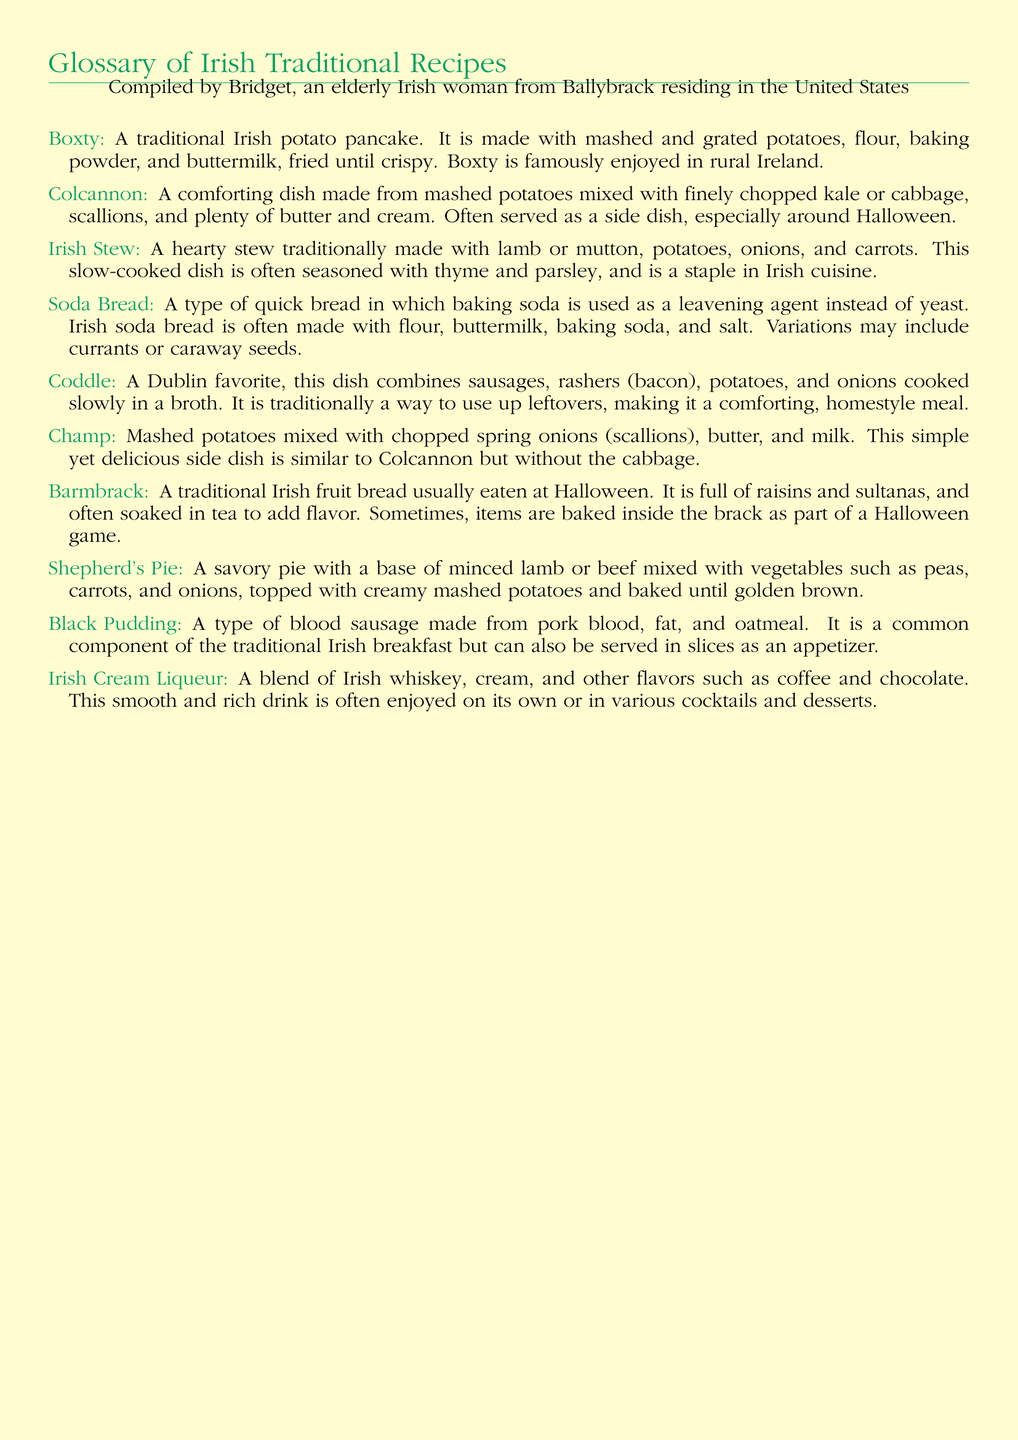What is Boxty? Boxty is defined in the document as a traditional Irish potato pancake made with mashed and grated potatoes, flour, baking powder, and buttermilk, fried until crispy.
Answer: A traditional Irish potato pancake What is Colcannon made from? The document states that Colcannon is made from mashed potatoes mixed with finely chopped kale or cabbage, scallions, and plenty of butter and cream.
Answer: Mashed potatoes, kale (or cabbage), scallions, butter, cream What key ingredient does Irish Soda Bread use as a leavening agent? According to the document, Irish Soda Bread uses baking soda as a leavening agent instead of yeast.
Answer: Baking soda What is a common component of a traditional Irish breakfast? The document mentions that Black Pudding is a common component of the traditional Irish breakfast.
Answer: Black Pudding What is the primary meat used in Shepherd's Pie? The document states that Shepherd's Pie has a base of minced lamb or beef.
Answer: Minced lamb (or beef) What type of bread is Barmbrack? Barmbrack is described in the document as a traditional Irish fruit bread usually eaten at Halloween.
Answer: Traditional Irish fruit bread What food does Coddle primarily use as ingredients? The document specifies Coddle combines sausages, rashers (bacon), potatoes, and onions.
Answer: Sausages, rashers (bacon), potatoes, onions What dish is similar to Champ but includes cabbage? The document indicates that Colcannon is similar to Champ but differs by including cabbage.
Answer: Colcannon 